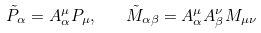Convert formula to latex. <formula><loc_0><loc_0><loc_500><loc_500>\tilde { P } _ { \alpha } = A _ { \alpha } ^ { \mu } P _ { \mu } , \quad \tilde { M } _ { \alpha \beta } = A _ { \alpha } ^ { \mu } A _ { \beta } ^ { \nu } M _ { \mu \nu }</formula> 